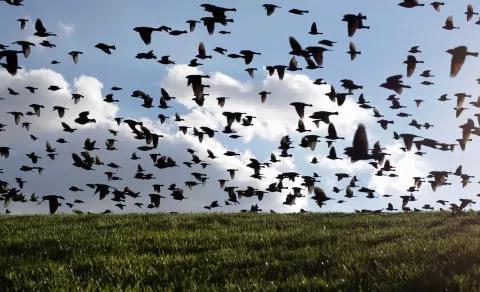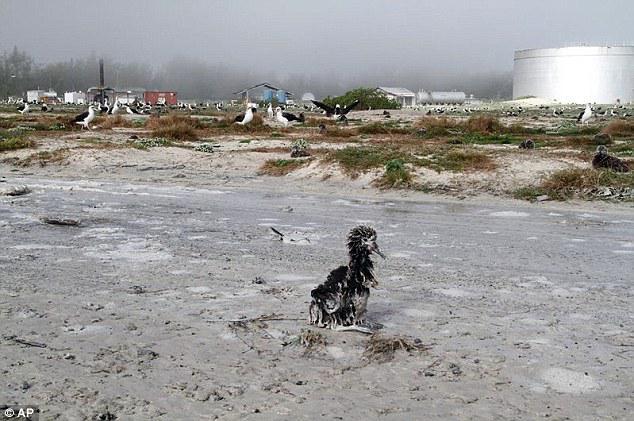The first image is the image on the left, the second image is the image on the right. Examine the images to the left and right. Is the description "Some of the birds in the image on the left are flying in the air." accurate? Answer yes or no. Yes. The first image is the image on the left, the second image is the image on the right. Analyze the images presented: Is the assertion "All birds are flying in the sky above a green field in one image." valid? Answer yes or no. Yes. 